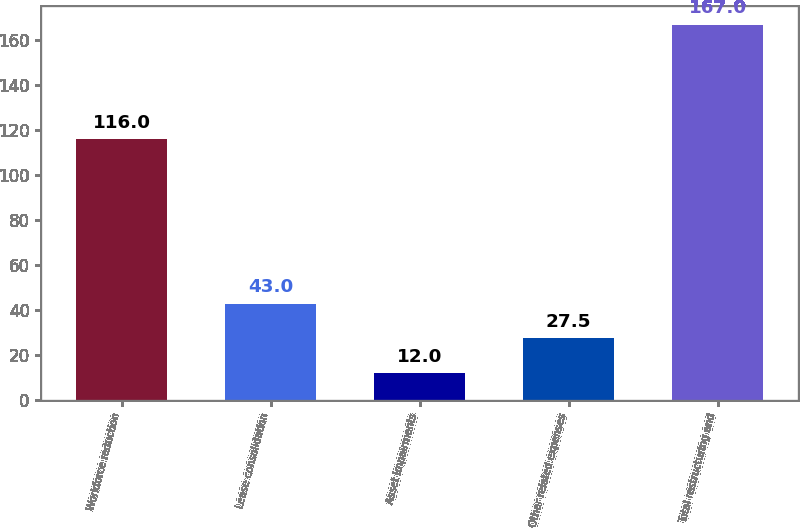<chart> <loc_0><loc_0><loc_500><loc_500><bar_chart><fcel>Workforce reduction<fcel>Lease consolidation<fcel>Asset impairments<fcel>Other related expenses<fcel>Total restructuring and<nl><fcel>116<fcel>43<fcel>12<fcel>27.5<fcel>167<nl></chart> 